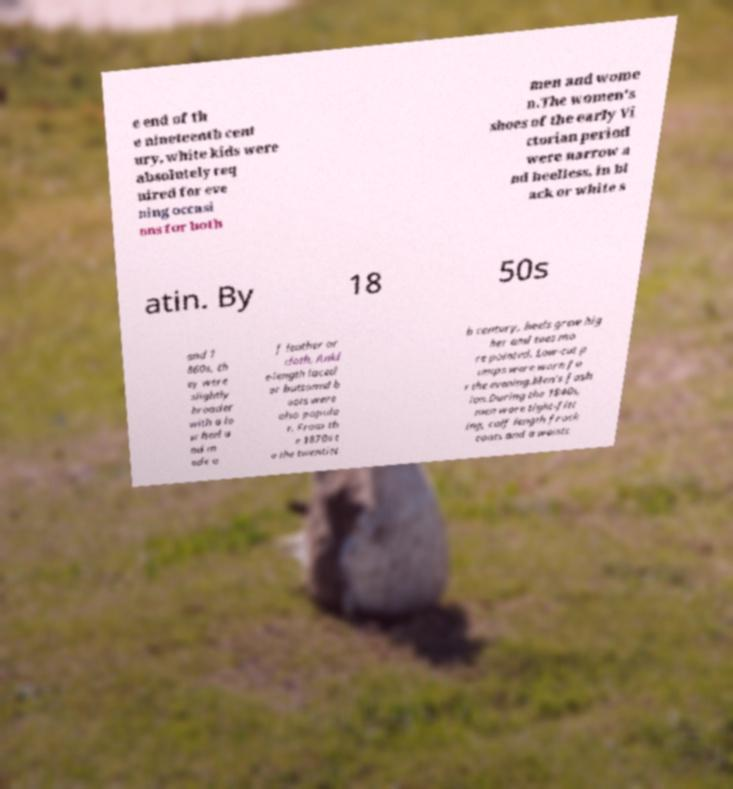What messages or text are displayed in this image? I need them in a readable, typed format. e end of th e nineteenth cent ury, white kids were absolutely req uired for eve ning occasi ons for both men and wome n.The women's shoes of the early Vi ctorian period were narrow a nd heelless, in bl ack or white s atin. By 18 50s and 1 860s, th ey were slightly broader with a lo w heel a nd m ade o f leather or cloth. Ankl e-length laced or buttoned b oots were also popula r. From th e 1870s t o the twentiet h century, heels grew hig her and toes mo re pointed. Low-cut p umps were worn fo r the evening.Men's fash ion.During the 1840s, men wore tight-fitt ing, calf length frock coats and a waistc 